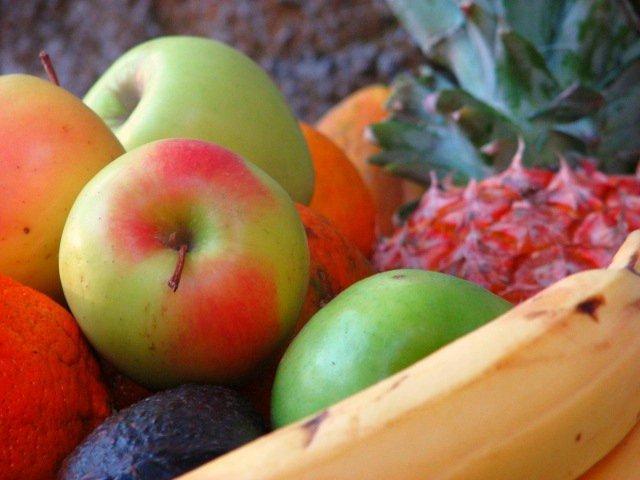How many bananas are in the picture?
Give a very brief answer. 1. How many apples look rotten?
Give a very brief answer. 0. How many apples are in the picture?
Give a very brief answer. 4. How many oranges are there?
Give a very brief answer. 2. How many mugs have a spoon resting inside them?
Give a very brief answer. 0. 